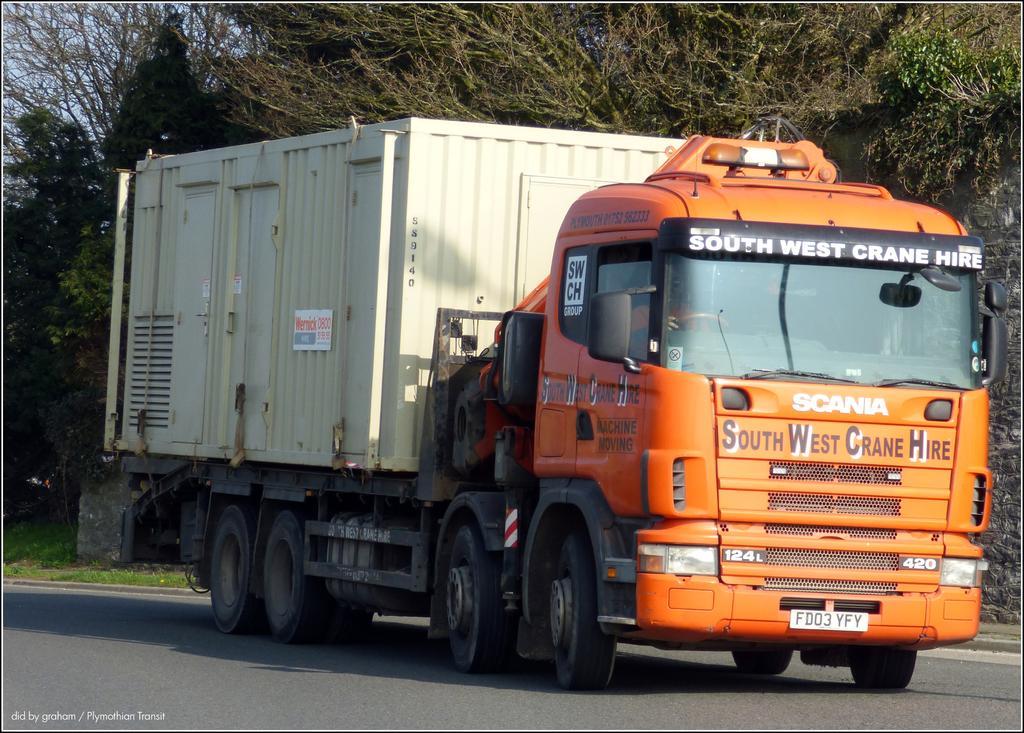Could you give a brief overview of what you see in this image? In this image there is a person driving the vehicle on the road. In the background of the image there are trees and sky. There is some text at the bottom of the image. 